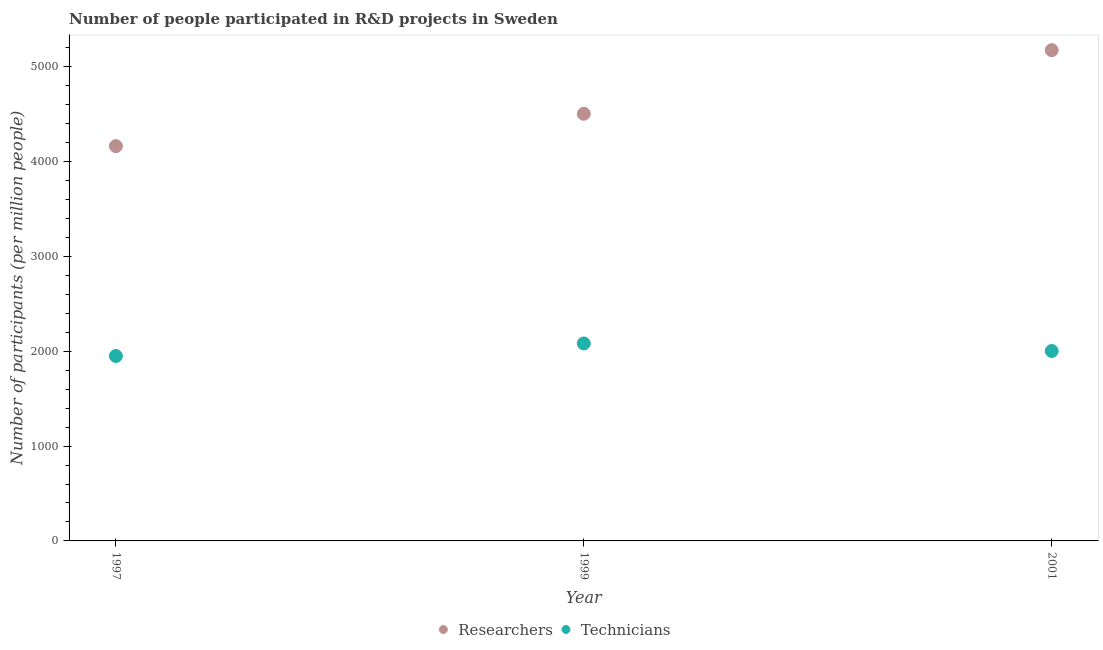How many different coloured dotlines are there?
Provide a short and direct response. 2. Is the number of dotlines equal to the number of legend labels?
Your answer should be very brief. Yes. What is the number of technicians in 1997?
Your response must be concise. 1950. Across all years, what is the maximum number of technicians?
Ensure brevity in your answer.  2082.24. Across all years, what is the minimum number of researchers?
Provide a short and direct response. 4162.72. In which year was the number of researchers maximum?
Offer a very short reply. 2001. In which year was the number of researchers minimum?
Your answer should be very brief. 1997. What is the total number of researchers in the graph?
Your answer should be compact. 1.38e+04. What is the difference between the number of researchers in 1999 and that in 2001?
Your answer should be compact. -670.7. What is the difference between the number of researchers in 1997 and the number of technicians in 1999?
Make the answer very short. 2080.48. What is the average number of technicians per year?
Provide a short and direct response. 2011.6. In the year 1997, what is the difference between the number of researchers and number of technicians?
Give a very brief answer. 2212.72. What is the ratio of the number of technicians in 1997 to that in 2001?
Offer a terse response. 0.97. Is the number of researchers in 1999 less than that in 2001?
Offer a very short reply. Yes. Is the difference between the number of researchers in 1999 and 2001 greater than the difference between the number of technicians in 1999 and 2001?
Offer a terse response. No. What is the difference between the highest and the second highest number of researchers?
Keep it short and to the point. 670.7. What is the difference between the highest and the lowest number of technicians?
Keep it short and to the point. 132.24. In how many years, is the number of technicians greater than the average number of technicians taken over all years?
Provide a short and direct response. 1. Does the number of researchers monotonically increase over the years?
Keep it short and to the point. Yes. Is the number of researchers strictly less than the number of technicians over the years?
Your answer should be compact. No. What is the difference between two consecutive major ticks on the Y-axis?
Your answer should be compact. 1000. Does the graph contain grids?
Your answer should be very brief. No. Where does the legend appear in the graph?
Make the answer very short. Bottom center. What is the title of the graph?
Offer a terse response. Number of people participated in R&D projects in Sweden. Does "Boys" appear as one of the legend labels in the graph?
Make the answer very short. No. What is the label or title of the Y-axis?
Provide a succinct answer. Number of participants (per million people). What is the Number of participants (per million people) of Researchers in 1997?
Your answer should be compact. 4162.72. What is the Number of participants (per million people) of Technicians in 1997?
Make the answer very short. 1950. What is the Number of participants (per million people) in Researchers in 1999?
Your answer should be very brief. 4503.9. What is the Number of participants (per million people) in Technicians in 1999?
Provide a succinct answer. 2082.24. What is the Number of participants (per million people) of Researchers in 2001?
Make the answer very short. 5174.6. What is the Number of participants (per million people) in Technicians in 2001?
Your answer should be very brief. 2002.57. Across all years, what is the maximum Number of participants (per million people) of Researchers?
Your answer should be compact. 5174.6. Across all years, what is the maximum Number of participants (per million people) in Technicians?
Your response must be concise. 2082.24. Across all years, what is the minimum Number of participants (per million people) of Researchers?
Ensure brevity in your answer.  4162.72. Across all years, what is the minimum Number of participants (per million people) in Technicians?
Give a very brief answer. 1950. What is the total Number of participants (per million people) in Researchers in the graph?
Offer a very short reply. 1.38e+04. What is the total Number of participants (per million people) of Technicians in the graph?
Ensure brevity in your answer.  6034.81. What is the difference between the Number of participants (per million people) in Researchers in 1997 and that in 1999?
Provide a short and direct response. -341.18. What is the difference between the Number of participants (per million people) in Technicians in 1997 and that in 1999?
Offer a terse response. -132.24. What is the difference between the Number of participants (per million people) of Researchers in 1997 and that in 2001?
Your response must be concise. -1011.88. What is the difference between the Number of participants (per million people) in Technicians in 1997 and that in 2001?
Your answer should be very brief. -52.56. What is the difference between the Number of participants (per million people) in Researchers in 1999 and that in 2001?
Your answer should be very brief. -670.7. What is the difference between the Number of participants (per million people) of Technicians in 1999 and that in 2001?
Offer a very short reply. 79.67. What is the difference between the Number of participants (per million people) of Researchers in 1997 and the Number of participants (per million people) of Technicians in 1999?
Your response must be concise. 2080.48. What is the difference between the Number of participants (per million people) in Researchers in 1997 and the Number of participants (per million people) in Technicians in 2001?
Your response must be concise. 2160.15. What is the difference between the Number of participants (per million people) of Researchers in 1999 and the Number of participants (per million people) of Technicians in 2001?
Provide a short and direct response. 2501.34. What is the average Number of participants (per million people) in Researchers per year?
Ensure brevity in your answer.  4613.74. What is the average Number of participants (per million people) of Technicians per year?
Your response must be concise. 2011.6. In the year 1997, what is the difference between the Number of participants (per million people) in Researchers and Number of participants (per million people) in Technicians?
Your answer should be compact. 2212.72. In the year 1999, what is the difference between the Number of participants (per million people) in Researchers and Number of participants (per million people) in Technicians?
Make the answer very short. 2421.66. In the year 2001, what is the difference between the Number of participants (per million people) of Researchers and Number of participants (per million people) of Technicians?
Provide a succinct answer. 3172.04. What is the ratio of the Number of participants (per million people) of Researchers in 1997 to that in 1999?
Offer a very short reply. 0.92. What is the ratio of the Number of participants (per million people) of Technicians in 1997 to that in 1999?
Your answer should be very brief. 0.94. What is the ratio of the Number of participants (per million people) in Researchers in 1997 to that in 2001?
Offer a very short reply. 0.8. What is the ratio of the Number of participants (per million people) in Technicians in 1997 to that in 2001?
Provide a succinct answer. 0.97. What is the ratio of the Number of participants (per million people) in Researchers in 1999 to that in 2001?
Your answer should be very brief. 0.87. What is the ratio of the Number of participants (per million people) of Technicians in 1999 to that in 2001?
Offer a terse response. 1.04. What is the difference between the highest and the second highest Number of participants (per million people) in Researchers?
Provide a succinct answer. 670.7. What is the difference between the highest and the second highest Number of participants (per million people) of Technicians?
Give a very brief answer. 79.67. What is the difference between the highest and the lowest Number of participants (per million people) of Researchers?
Your answer should be very brief. 1011.88. What is the difference between the highest and the lowest Number of participants (per million people) in Technicians?
Your answer should be very brief. 132.24. 